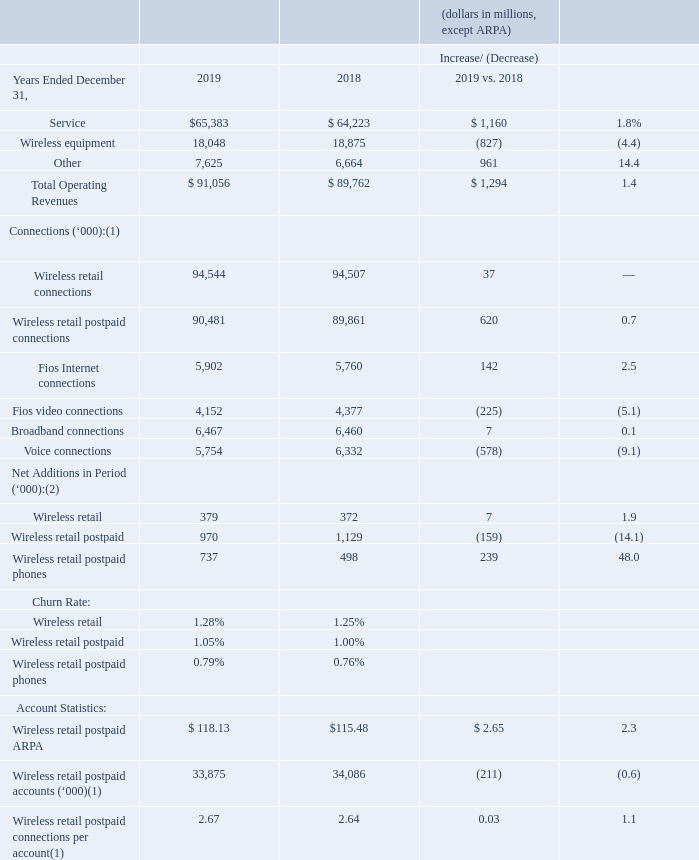Operating Revenues and Selected Operating Statistics
(1) As of end of period (2) Excluding acquisitions and adjustments.
Consumer’s total operating revenues increased $1.3 billion, or 1.4%, during 2019 compared to 2018, primarily as a result of increases in Service and Other revenues, partially offset by a decrease in Wireless equipment revenue.
Service Revenue Service revenue increased $1.2 billion, or 1.8%, during 2019 compared to 2018, primarily due to increases in wireless service and Fios revenues, partially offset by decreases in wireline voice and DSL services.
Wireless service revenue increased $1.3 billion, or 2.5%, during 2019 compared to 2018, due to increases in wireless access revenue, driven by customers shifting to higher access plans including unlimited plans and increases in the number of devices per account, the declining fixed-term subsidized plan base and growth from reseller accounts. Wireless retail postpaid ARPA increased 2.3%.
For the year ended December 31, 2019, Fios revenues totaled $10.4 billion and increased $92 million, or 0.9%, compared to 2018. This increase was due to a 2.5% increase in Fios Internet connections, reflecting increased demand in higher broadband speeds, partially offset by a 5.1% decrease in Fios video connections, reflecting the ongoing shift from traditional linear video to over-the-top (OTT) offerings.
Service revenue attributable to wireline voice and DSL broadband services declined during 2019, compared to 2018. The declines are primarily due to a decrease of 9.1% in voice connections resulting primarily from competition and technology substitution with wireless and competing Voice over Internet Protocol (VoIP) and cable telephony services.
Wireless Equipment Revenue Wireless equipment revenue decreased $827 million, or 4.4%, during 2019 compared to 2018, as a result of declines in wireless device sales primarily due to an elongation of the handset upgrade cycle and increased promotions. These decreases were partially offset by a shift to higher priced units in the mix of wireless devices sold.
Other Revenue Other revenue includes non-service revenues such as regulatory fees, cost recovery surcharges, revenues associated with our device protection package, leasing and interest on equipment financed under a device payment plan agreement when sold to the customer by an authorized agent. Other revenue increased $1.0 billion, or 14.4%, during 2019 compared to 2018, primarily due to pricing increases related to our wireless device protection plans, as well as regulatory fees.
How much did Consumer’s total operating revenues increase in 2019? $1.3 billion. Why did Consumer’s total operating revenues increase in 2019? As a result of increases in service and other revenues, partially offset by a decrease in wireless equipment revenue. How much did Service Revenue increase in 2019? $1.2 billion. What is the change in Service revenue from 2018 to 2019?
Answer scale should be: million. 65,383-64,223
Answer: 1160. What is the change in Wireless equipment revenue from 2018 to 2019?
Answer scale should be: million. 18,048-18,875
Answer: -827. What is the change in Total Operating Revenues from 2018 to 2019?
Answer scale should be: million. 91,056-89,762
Answer: 1294. 